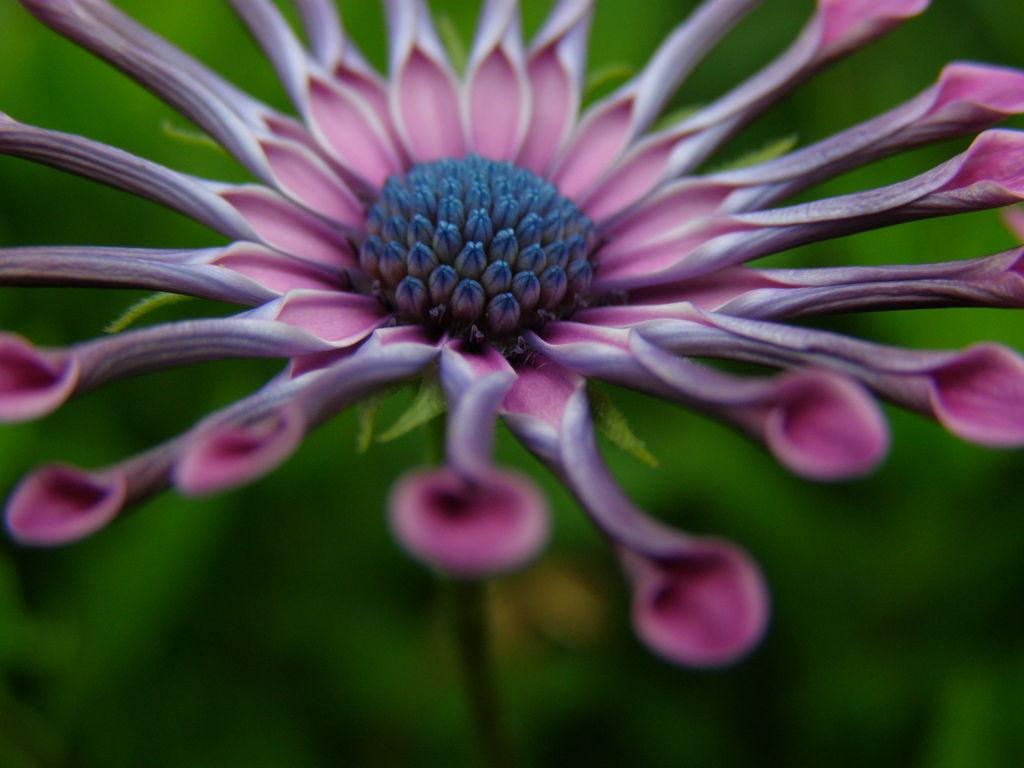What is the main subject of the image? There is a flower in the image. Can you describe the background of the image? The background of the image is blurred. What type of wool is being used to create the flower in the image? There is no wool present in the image; the flower is a natural object. Where is the sink located in the image? There is no sink present in the image; it only features a flower and a blurred background. 